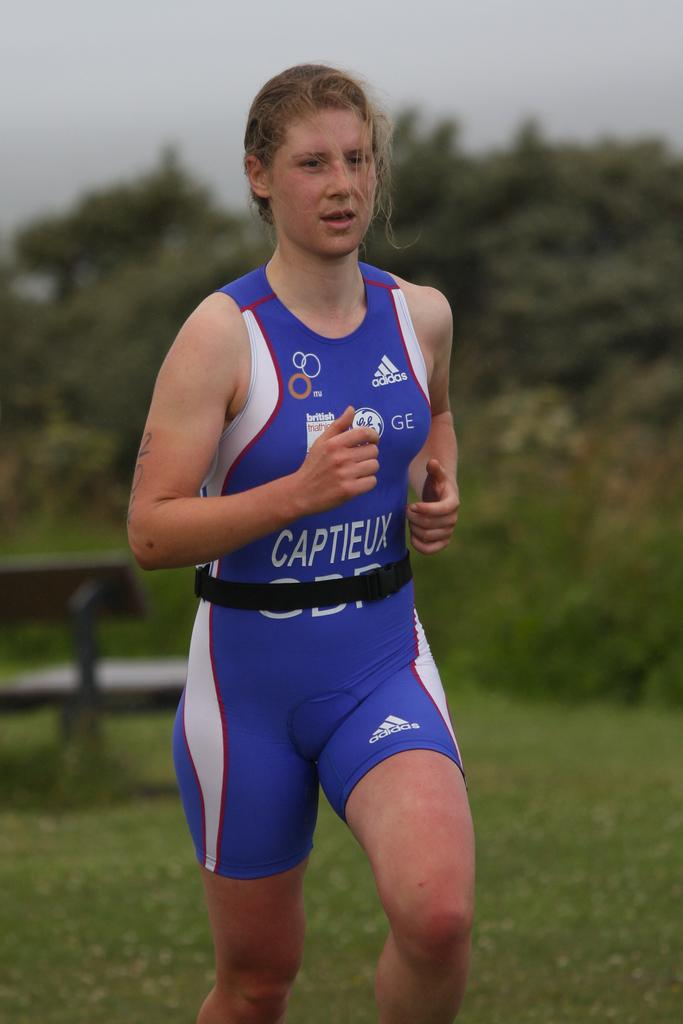<image>
Create a compact narrative representing the image presented. A woman wearing a Capiteux uniform is running a race. 